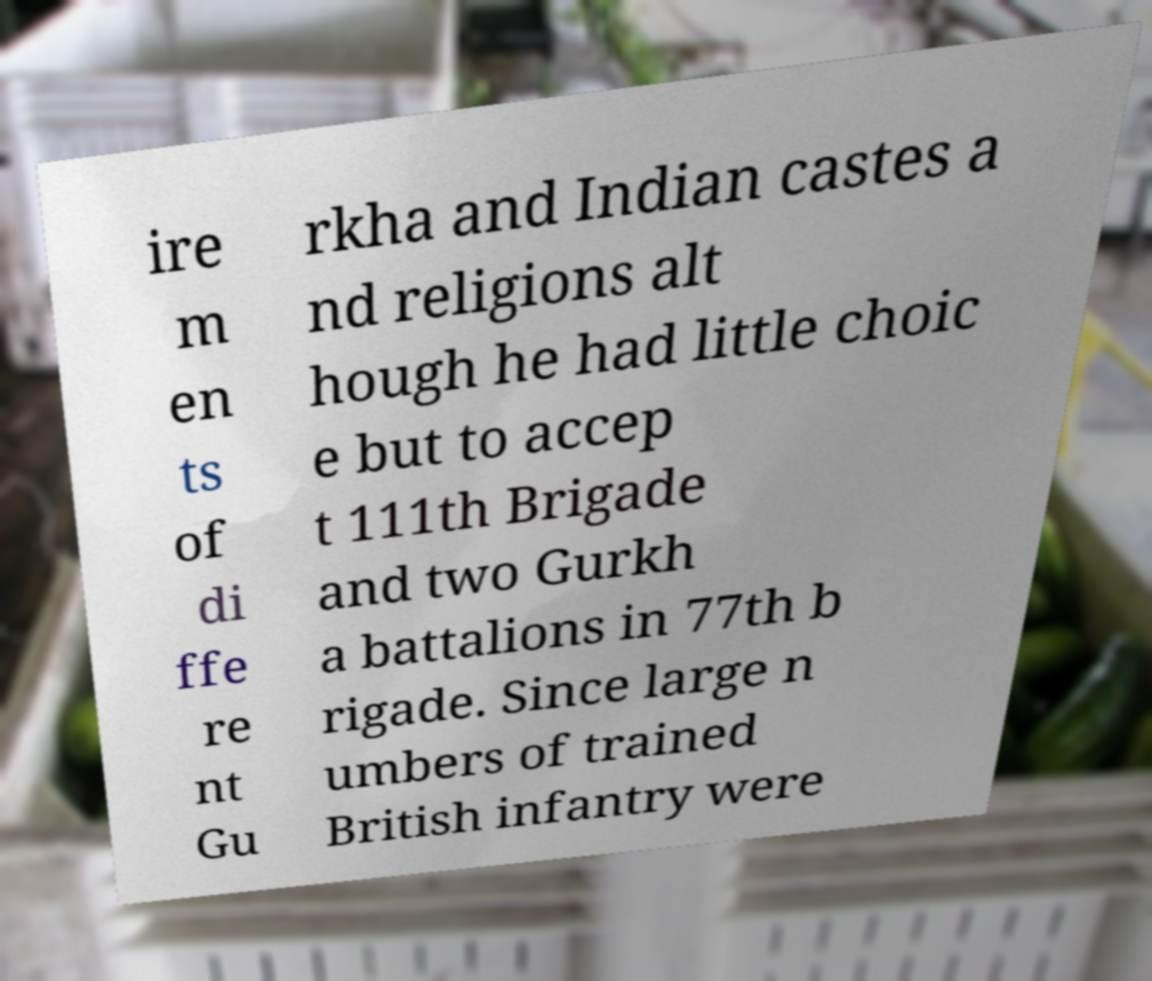What messages or text are displayed in this image? I need them in a readable, typed format. ire m en ts of di ffe re nt Gu rkha and Indian castes a nd religions alt hough he had little choic e but to accep t 111th Brigade and two Gurkh a battalions in 77th b rigade. Since large n umbers of trained British infantry were 